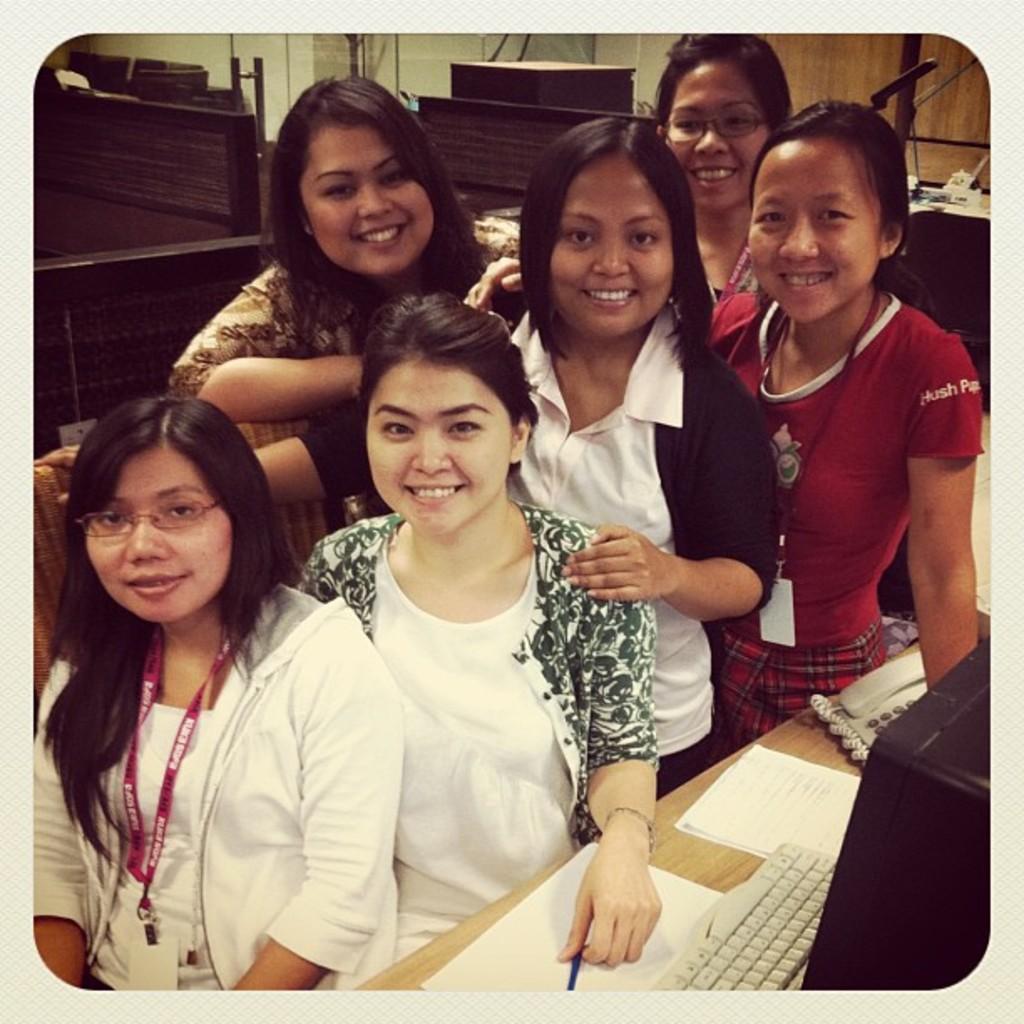How would you summarize this image in a sentence or two? In the picture I can see some persons standing and posing for a photograph, on right side of the picture there is monitor screen, keyboard, telephone on table and in the background there are some wooden objects. 